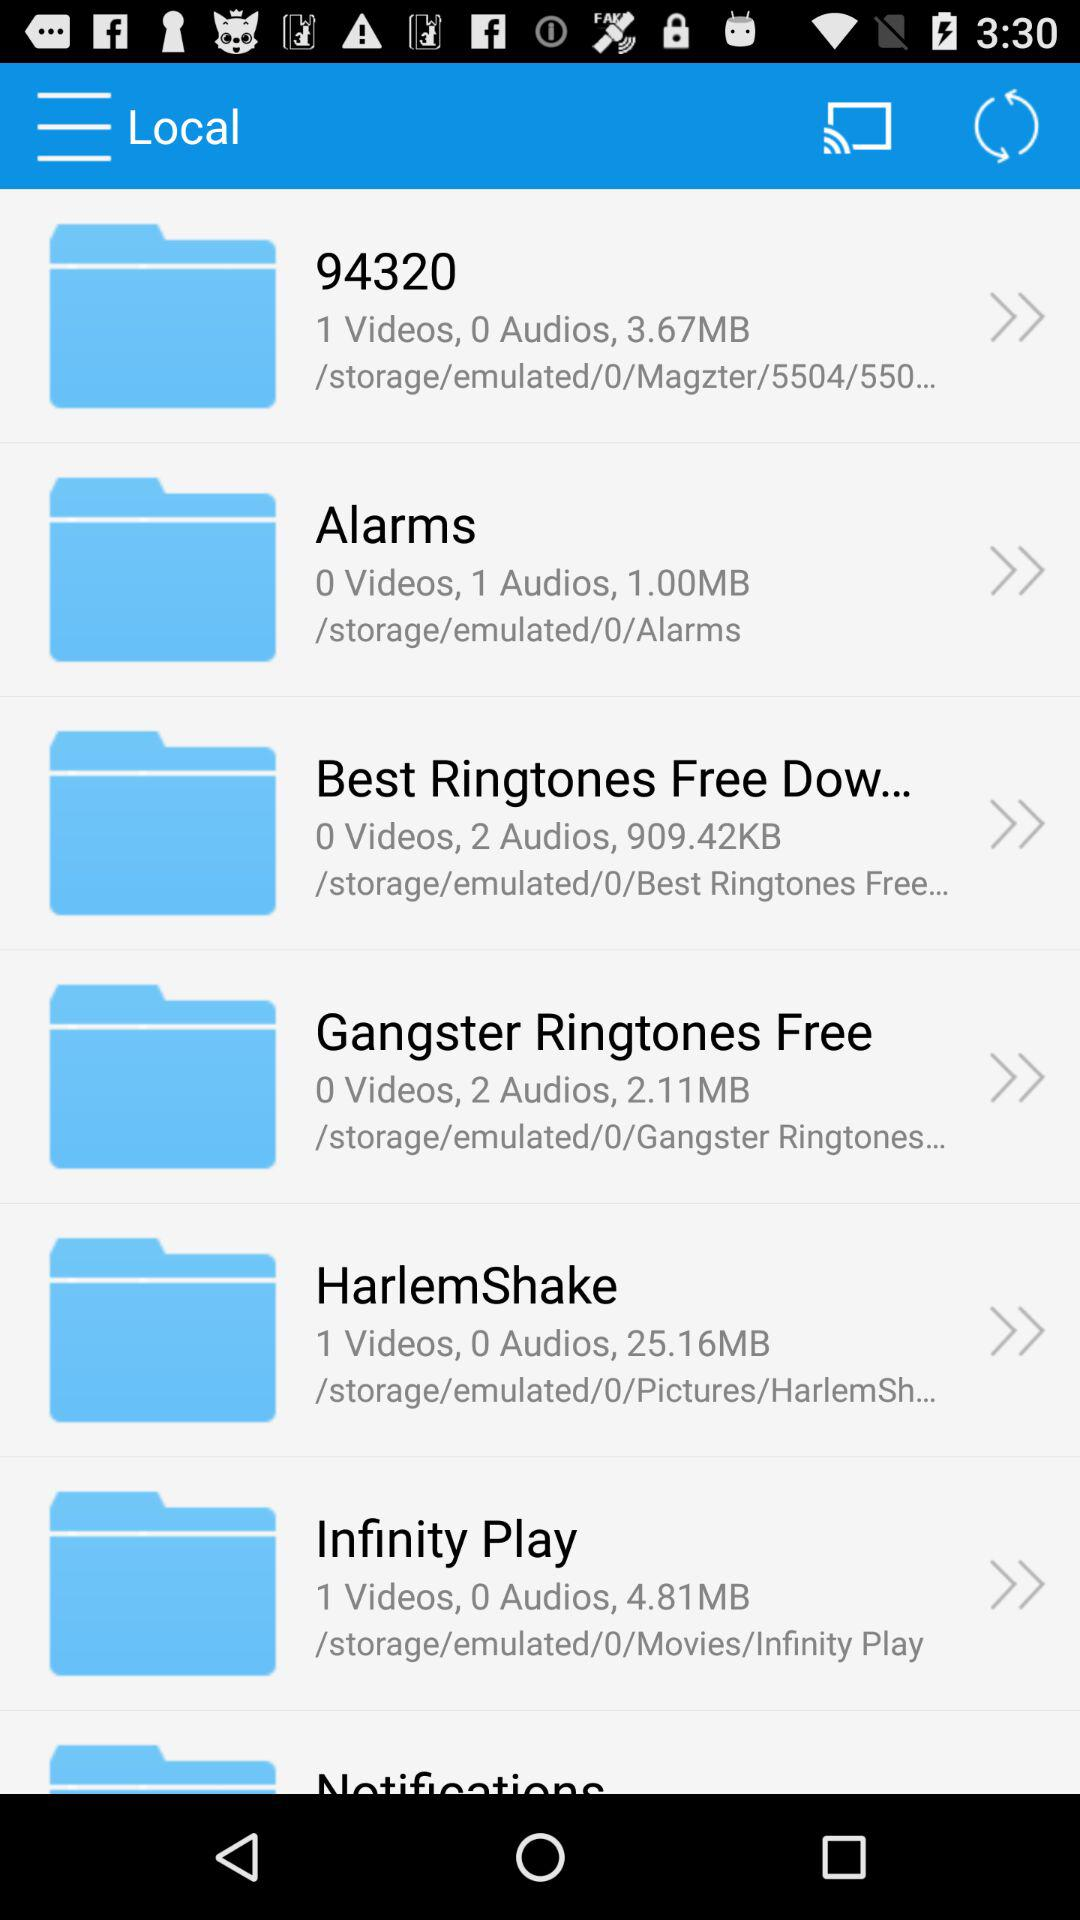Which folder has a size of 1.00 MB? The folder that has a size of 1.00 MB is "Alarms". 